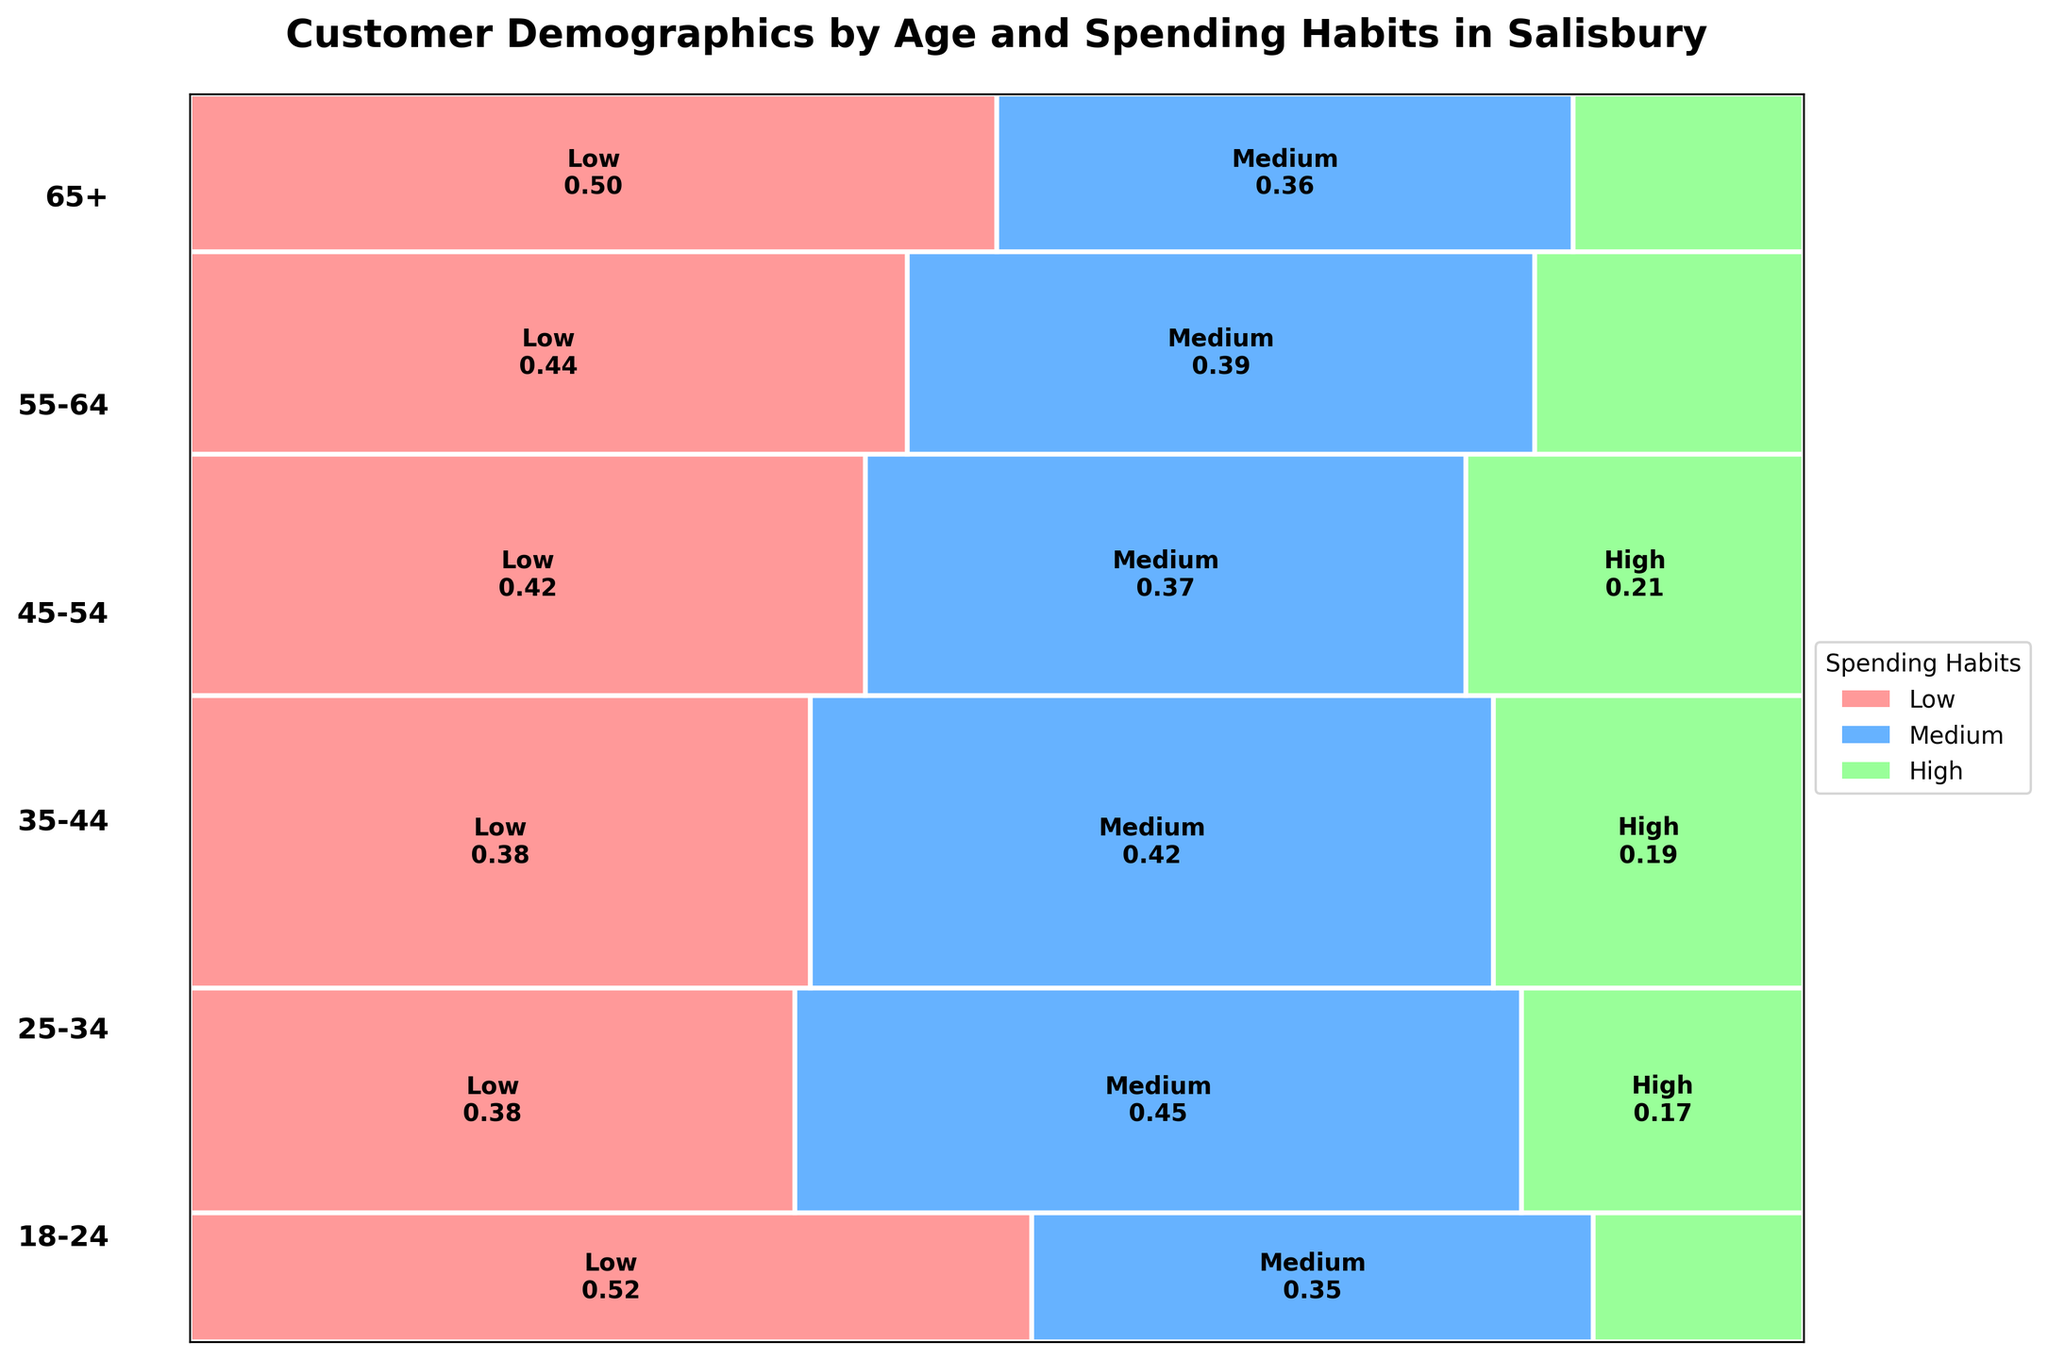What is the title of the plot? The title of the plot is located at the top-center of the plot and gives a succinct summary of what the plot displays. It reads, "Customer Demographics by Age and Spending Habits in Salisbury".
Answer: Customer Demographics by Age and Spending Habits in Salisbury How many age groups are displayed in the plot? The age groups are labeled to the left of the plot in bold text. By counting these labels, we can determine the number of age groups.
Answer: 6 What are the colors used to represent the different spending habits? The plot color-codes spending habits using distinct colors, which are noted in the legend on the right side. The colors used are light red for "Low", light blue for "Medium", and light green for "High".
Answer: Light red, light blue, light green Which age group has the highest proportion of high spending habits? By examining the rectangles that are color-coded green and comparing their widths within each age group, we see that the 35-44 age group has the widest green rectangle, indicating the highest proportion of high spending habits.
Answer: 35-44 What is the proportion of low spending habits for the 18-24 age group? Look at the width of the light red rectangles within the 18-24 age group section in the plot. The axis scaling and added text in the rectangle clarify this proportion. The labeled text indicates this proportion is 0.60.
Answer: 0.60 Which spending habit category is the smallest for the 55-64 age group? We compare the widths of rectangles within the 55-64 age group. The smallest width corresponds to the green color, representing high spending habits.
Answer: High Which age group has the highest total number of customers? By observing the height of the rectangles stacked within each age group, the age group with the tallest overall height is the 35-44 age group. This indicates the highest total number of customers.
Answer: 35-44 How does the proportion of medium spending habits for the 65+ age group compare to the low spending habits? For the 65+ age group, compare the widths of the blue rectangle (medium spending) and the red rectangle (low spending). The blue rectangle is narrower than the red one, indicating a smaller proportion of medium spending habits relative to low spending habits.
Answer: Smaller What is the total count of high spenders in the 25-34 and 35-44 age groups? Add the counts of high spenders for the 25-34 and 35-44 age groups as listed in the provided data: 70 (25-34) + 100 (35-44) = 170.
Answer: 170 